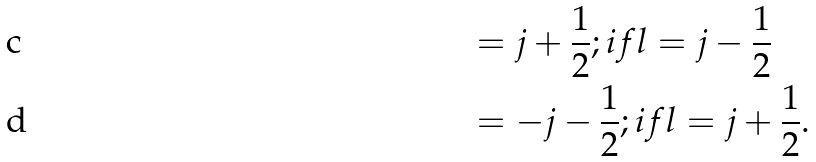<formula> <loc_0><loc_0><loc_500><loc_500>& = j + \frac { 1 } { 2 } ; i f l = j - \frac { 1 } { 2 } \\ & = - j - \frac { 1 } { 2 } ; i f l = j + \frac { 1 } { 2 } .</formula> 